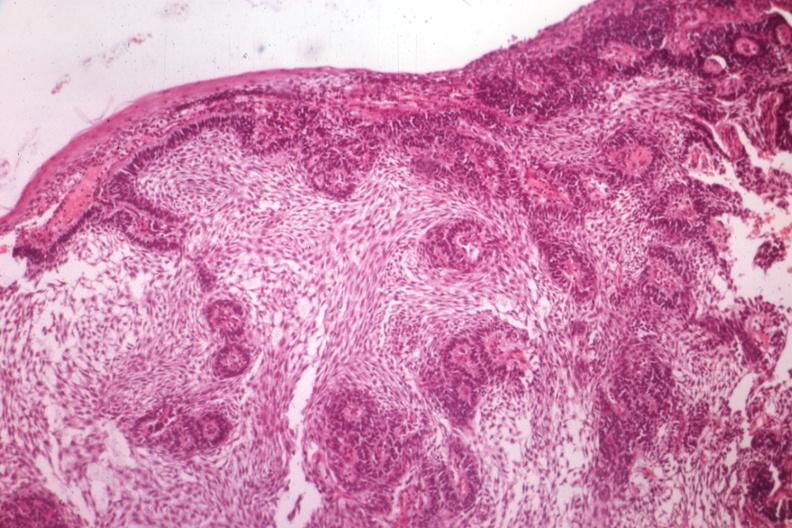s cervical leiomyoma a guess?
Answer the question using a single word or phrase. No 